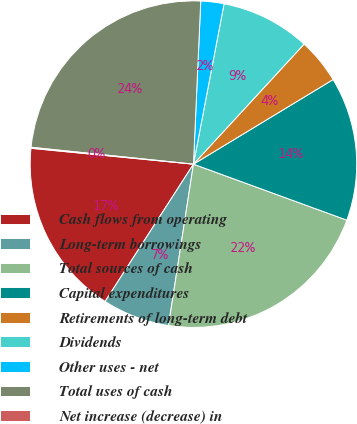Convert chart to OTSL. <chart><loc_0><loc_0><loc_500><loc_500><pie_chart><fcel>Cash flows from operating<fcel>Long-term borrowings<fcel>Total sources of cash<fcel>Capital expenditures<fcel>Retirements of long-term debt<fcel>Dividends<fcel>Other uses - net<fcel>Total uses of cash<fcel>Net increase (decrease) in<nl><fcel>17.45%<fcel>6.66%<fcel>21.87%<fcel>14.24%<fcel>4.48%<fcel>8.85%<fcel>2.29%<fcel>24.06%<fcel>0.1%<nl></chart> 